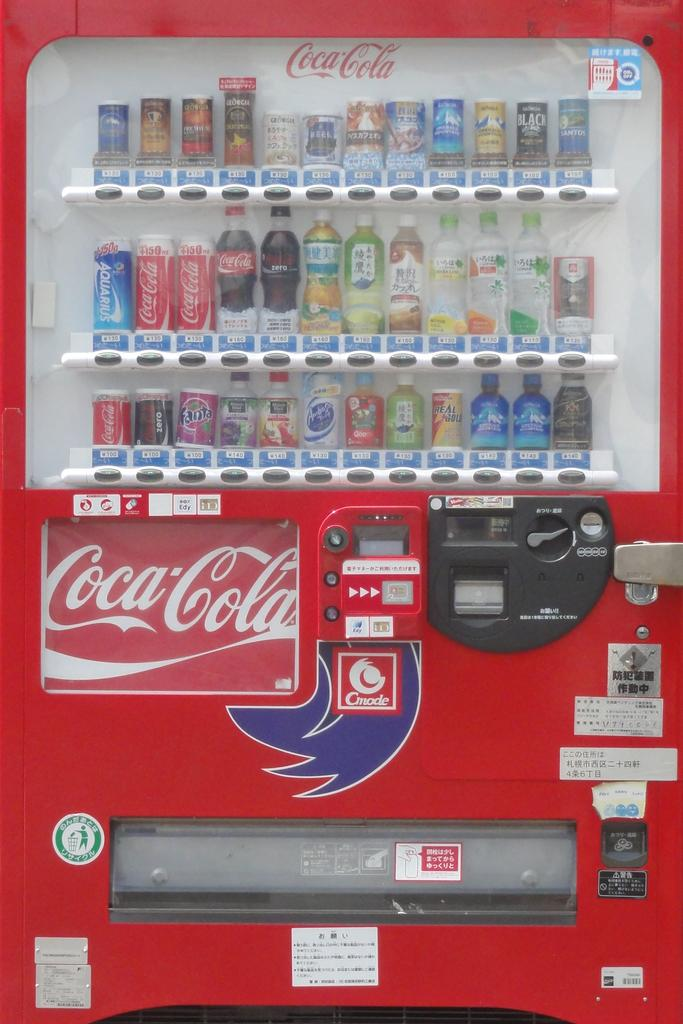<image>
Create a compact narrative representing the image presented. A large red Coca cola vending machine with a Cmode logo on it 